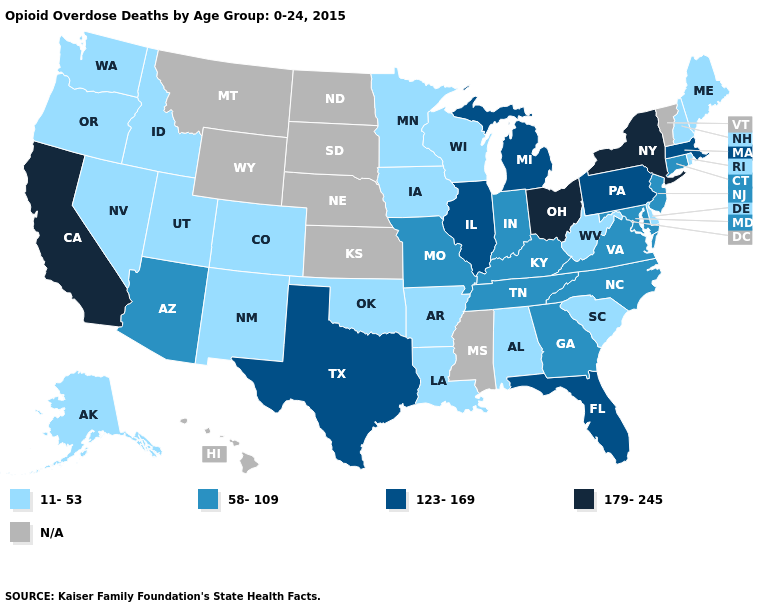Does Ohio have the highest value in the USA?
Give a very brief answer. Yes. What is the lowest value in the USA?
Be succinct. 11-53. Which states have the lowest value in the USA?
Concise answer only. Alabama, Alaska, Arkansas, Colorado, Delaware, Idaho, Iowa, Louisiana, Maine, Minnesota, Nevada, New Hampshire, New Mexico, Oklahoma, Oregon, Rhode Island, South Carolina, Utah, Washington, West Virginia, Wisconsin. What is the value of Texas?
Write a very short answer. 123-169. Name the states that have a value in the range N/A?
Write a very short answer. Hawaii, Kansas, Mississippi, Montana, Nebraska, North Dakota, South Dakota, Vermont, Wyoming. What is the value of South Dakota?
Write a very short answer. N/A. Among the states that border Kentucky , does Illinois have the highest value?
Write a very short answer. No. Which states hav the highest value in the South?
Answer briefly. Florida, Texas. Does Missouri have the lowest value in the USA?
Concise answer only. No. What is the value of Montana?
Answer briefly. N/A. Among the states that border Nebraska , does Colorado have the highest value?
Answer briefly. No. Name the states that have a value in the range 179-245?
Be succinct. California, New York, Ohio. Name the states that have a value in the range N/A?
Concise answer only. Hawaii, Kansas, Mississippi, Montana, Nebraska, North Dakota, South Dakota, Vermont, Wyoming. 